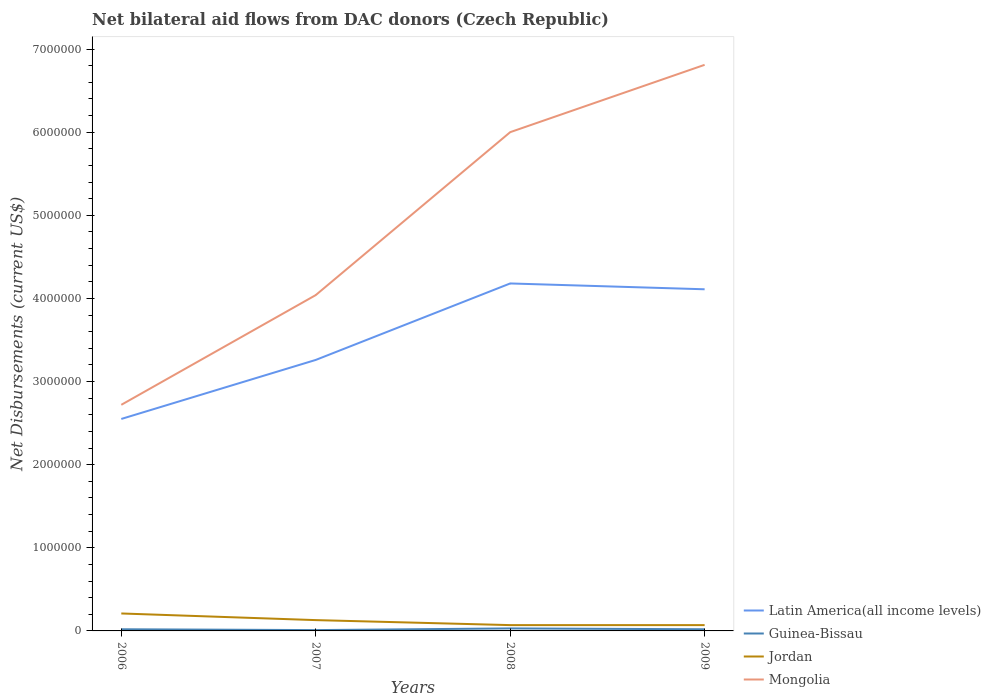How many different coloured lines are there?
Offer a terse response. 4. Across all years, what is the maximum net bilateral aid flows in Mongolia?
Your answer should be very brief. 2.72e+06. What is the total net bilateral aid flows in Mongolia in the graph?
Your answer should be very brief. -4.09e+06. Is the net bilateral aid flows in Jordan strictly greater than the net bilateral aid flows in Latin America(all income levels) over the years?
Your answer should be compact. Yes. How many lines are there?
Provide a short and direct response. 4. Does the graph contain any zero values?
Make the answer very short. No. Where does the legend appear in the graph?
Ensure brevity in your answer.  Bottom right. How are the legend labels stacked?
Make the answer very short. Vertical. What is the title of the graph?
Your answer should be compact. Net bilateral aid flows from DAC donors (Czech Republic). Does "Gambia, The" appear as one of the legend labels in the graph?
Offer a terse response. No. What is the label or title of the X-axis?
Offer a very short reply. Years. What is the label or title of the Y-axis?
Offer a very short reply. Net Disbursements (current US$). What is the Net Disbursements (current US$) of Latin America(all income levels) in 2006?
Provide a succinct answer. 2.55e+06. What is the Net Disbursements (current US$) in Jordan in 2006?
Keep it short and to the point. 2.10e+05. What is the Net Disbursements (current US$) of Mongolia in 2006?
Keep it short and to the point. 2.72e+06. What is the Net Disbursements (current US$) in Latin America(all income levels) in 2007?
Offer a terse response. 3.26e+06. What is the Net Disbursements (current US$) of Guinea-Bissau in 2007?
Give a very brief answer. 10000. What is the Net Disbursements (current US$) of Jordan in 2007?
Offer a terse response. 1.30e+05. What is the Net Disbursements (current US$) of Mongolia in 2007?
Keep it short and to the point. 4.04e+06. What is the Net Disbursements (current US$) in Latin America(all income levels) in 2008?
Your answer should be compact. 4.18e+06. What is the Net Disbursements (current US$) of Guinea-Bissau in 2008?
Your answer should be compact. 3.00e+04. What is the Net Disbursements (current US$) in Latin America(all income levels) in 2009?
Give a very brief answer. 4.11e+06. What is the Net Disbursements (current US$) of Guinea-Bissau in 2009?
Your response must be concise. 2.00e+04. What is the Net Disbursements (current US$) in Mongolia in 2009?
Give a very brief answer. 6.81e+06. Across all years, what is the maximum Net Disbursements (current US$) of Latin America(all income levels)?
Offer a very short reply. 4.18e+06. Across all years, what is the maximum Net Disbursements (current US$) of Guinea-Bissau?
Provide a short and direct response. 3.00e+04. Across all years, what is the maximum Net Disbursements (current US$) of Mongolia?
Provide a short and direct response. 6.81e+06. Across all years, what is the minimum Net Disbursements (current US$) of Latin America(all income levels)?
Offer a terse response. 2.55e+06. Across all years, what is the minimum Net Disbursements (current US$) in Mongolia?
Your answer should be very brief. 2.72e+06. What is the total Net Disbursements (current US$) in Latin America(all income levels) in the graph?
Make the answer very short. 1.41e+07. What is the total Net Disbursements (current US$) in Mongolia in the graph?
Your answer should be compact. 1.96e+07. What is the difference between the Net Disbursements (current US$) of Latin America(all income levels) in 2006 and that in 2007?
Make the answer very short. -7.10e+05. What is the difference between the Net Disbursements (current US$) of Guinea-Bissau in 2006 and that in 2007?
Provide a short and direct response. 10000. What is the difference between the Net Disbursements (current US$) of Jordan in 2006 and that in 2007?
Your answer should be very brief. 8.00e+04. What is the difference between the Net Disbursements (current US$) of Mongolia in 2006 and that in 2007?
Your answer should be compact. -1.32e+06. What is the difference between the Net Disbursements (current US$) in Latin America(all income levels) in 2006 and that in 2008?
Keep it short and to the point. -1.63e+06. What is the difference between the Net Disbursements (current US$) of Jordan in 2006 and that in 2008?
Ensure brevity in your answer.  1.40e+05. What is the difference between the Net Disbursements (current US$) in Mongolia in 2006 and that in 2008?
Offer a terse response. -3.28e+06. What is the difference between the Net Disbursements (current US$) of Latin America(all income levels) in 2006 and that in 2009?
Provide a succinct answer. -1.56e+06. What is the difference between the Net Disbursements (current US$) in Mongolia in 2006 and that in 2009?
Ensure brevity in your answer.  -4.09e+06. What is the difference between the Net Disbursements (current US$) in Latin America(all income levels) in 2007 and that in 2008?
Keep it short and to the point. -9.20e+05. What is the difference between the Net Disbursements (current US$) in Mongolia in 2007 and that in 2008?
Keep it short and to the point. -1.96e+06. What is the difference between the Net Disbursements (current US$) of Latin America(all income levels) in 2007 and that in 2009?
Your answer should be very brief. -8.50e+05. What is the difference between the Net Disbursements (current US$) of Guinea-Bissau in 2007 and that in 2009?
Make the answer very short. -10000. What is the difference between the Net Disbursements (current US$) in Jordan in 2007 and that in 2009?
Offer a terse response. 6.00e+04. What is the difference between the Net Disbursements (current US$) in Mongolia in 2007 and that in 2009?
Your answer should be compact. -2.77e+06. What is the difference between the Net Disbursements (current US$) in Latin America(all income levels) in 2008 and that in 2009?
Give a very brief answer. 7.00e+04. What is the difference between the Net Disbursements (current US$) in Guinea-Bissau in 2008 and that in 2009?
Offer a terse response. 10000. What is the difference between the Net Disbursements (current US$) of Mongolia in 2008 and that in 2009?
Offer a very short reply. -8.10e+05. What is the difference between the Net Disbursements (current US$) of Latin America(all income levels) in 2006 and the Net Disbursements (current US$) of Guinea-Bissau in 2007?
Keep it short and to the point. 2.54e+06. What is the difference between the Net Disbursements (current US$) of Latin America(all income levels) in 2006 and the Net Disbursements (current US$) of Jordan in 2007?
Offer a very short reply. 2.42e+06. What is the difference between the Net Disbursements (current US$) in Latin America(all income levels) in 2006 and the Net Disbursements (current US$) in Mongolia in 2007?
Your response must be concise. -1.49e+06. What is the difference between the Net Disbursements (current US$) in Guinea-Bissau in 2006 and the Net Disbursements (current US$) in Jordan in 2007?
Your answer should be very brief. -1.10e+05. What is the difference between the Net Disbursements (current US$) in Guinea-Bissau in 2006 and the Net Disbursements (current US$) in Mongolia in 2007?
Make the answer very short. -4.02e+06. What is the difference between the Net Disbursements (current US$) in Jordan in 2006 and the Net Disbursements (current US$) in Mongolia in 2007?
Keep it short and to the point. -3.83e+06. What is the difference between the Net Disbursements (current US$) in Latin America(all income levels) in 2006 and the Net Disbursements (current US$) in Guinea-Bissau in 2008?
Make the answer very short. 2.52e+06. What is the difference between the Net Disbursements (current US$) of Latin America(all income levels) in 2006 and the Net Disbursements (current US$) of Jordan in 2008?
Your response must be concise. 2.48e+06. What is the difference between the Net Disbursements (current US$) in Latin America(all income levels) in 2006 and the Net Disbursements (current US$) in Mongolia in 2008?
Give a very brief answer. -3.45e+06. What is the difference between the Net Disbursements (current US$) of Guinea-Bissau in 2006 and the Net Disbursements (current US$) of Mongolia in 2008?
Make the answer very short. -5.98e+06. What is the difference between the Net Disbursements (current US$) in Jordan in 2006 and the Net Disbursements (current US$) in Mongolia in 2008?
Offer a very short reply. -5.79e+06. What is the difference between the Net Disbursements (current US$) of Latin America(all income levels) in 2006 and the Net Disbursements (current US$) of Guinea-Bissau in 2009?
Keep it short and to the point. 2.53e+06. What is the difference between the Net Disbursements (current US$) of Latin America(all income levels) in 2006 and the Net Disbursements (current US$) of Jordan in 2009?
Ensure brevity in your answer.  2.48e+06. What is the difference between the Net Disbursements (current US$) of Latin America(all income levels) in 2006 and the Net Disbursements (current US$) of Mongolia in 2009?
Keep it short and to the point. -4.26e+06. What is the difference between the Net Disbursements (current US$) of Guinea-Bissau in 2006 and the Net Disbursements (current US$) of Mongolia in 2009?
Ensure brevity in your answer.  -6.79e+06. What is the difference between the Net Disbursements (current US$) in Jordan in 2006 and the Net Disbursements (current US$) in Mongolia in 2009?
Give a very brief answer. -6.60e+06. What is the difference between the Net Disbursements (current US$) in Latin America(all income levels) in 2007 and the Net Disbursements (current US$) in Guinea-Bissau in 2008?
Your answer should be very brief. 3.23e+06. What is the difference between the Net Disbursements (current US$) in Latin America(all income levels) in 2007 and the Net Disbursements (current US$) in Jordan in 2008?
Your answer should be compact. 3.19e+06. What is the difference between the Net Disbursements (current US$) in Latin America(all income levels) in 2007 and the Net Disbursements (current US$) in Mongolia in 2008?
Ensure brevity in your answer.  -2.74e+06. What is the difference between the Net Disbursements (current US$) in Guinea-Bissau in 2007 and the Net Disbursements (current US$) in Jordan in 2008?
Give a very brief answer. -6.00e+04. What is the difference between the Net Disbursements (current US$) in Guinea-Bissau in 2007 and the Net Disbursements (current US$) in Mongolia in 2008?
Your response must be concise. -5.99e+06. What is the difference between the Net Disbursements (current US$) of Jordan in 2007 and the Net Disbursements (current US$) of Mongolia in 2008?
Your response must be concise. -5.87e+06. What is the difference between the Net Disbursements (current US$) of Latin America(all income levels) in 2007 and the Net Disbursements (current US$) of Guinea-Bissau in 2009?
Offer a very short reply. 3.24e+06. What is the difference between the Net Disbursements (current US$) of Latin America(all income levels) in 2007 and the Net Disbursements (current US$) of Jordan in 2009?
Keep it short and to the point. 3.19e+06. What is the difference between the Net Disbursements (current US$) of Latin America(all income levels) in 2007 and the Net Disbursements (current US$) of Mongolia in 2009?
Your answer should be very brief. -3.55e+06. What is the difference between the Net Disbursements (current US$) of Guinea-Bissau in 2007 and the Net Disbursements (current US$) of Mongolia in 2009?
Provide a succinct answer. -6.80e+06. What is the difference between the Net Disbursements (current US$) of Jordan in 2007 and the Net Disbursements (current US$) of Mongolia in 2009?
Provide a succinct answer. -6.68e+06. What is the difference between the Net Disbursements (current US$) in Latin America(all income levels) in 2008 and the Net Disbursements (current US$) in Guinea-Bissau in 2009?
Your answer should be very brief. 4.16e+06. What is the difference between the Net Disbursements (current US$) in Latin America(all income levels) in 2008 and the Net Disbursements (current US$) in Jordan in 2009?
Make the answer very short. 4.11e+06. What is the difference between the Net Disbursements (current US$) in Latin America(all income levels) in 2008 and the Net Disbursements (current US$) in Mongolia in 2009?
Offer a very short reply. -2.63e+06. What is the difference between the Net Disbursements (current US$) of Guinea-Bissau in 2008 and the Net Disbursements (current US$) of Mongolia in 2009?
Your response must be concise. -6.78e+06. What is the difference between the Net Disbursements (current US$) of Jordan in 2008 and the Net Disbursements (current US$) of Mongolia in 2009?
Give a very brief answer. -6.74e+06. What is the average Net Disbursements (current US$) of Latin America(all income levels) per year?
Ensure brevity in your answer.  3.52e+06. What is the average Net Disbursements (current US$) in Jordan per year?
Make the answer very short. 1.20e+05. What is the average Net Disbursements (current US$) in Mongolia per year?
Ensure brevity in your answer.  4.89e+06. In the year 2006, what is the difference between the Net Disbursements (current US$) in Latin America(all income levels) and Net Disbursements (current US$) in Guinea-Bissau?
Offer a very short reply. 2.53e+06. In the year 2006, what is the difference between the Net Disbursements (current US$) of Latin America(all income levels) and Net Disbursements (current US$) of Jordan?
Provide a succinct answer. 2.34e+06. In the year 2006, what is the difference between the Net Disbursements (current US$) of Guinea-Bissau and Net Disbursements (current US$) of Mongolia?
Offer a terse response. -2.70e+06. In the year 2006, what is the difference between the Net Disbursements (current US$) of Jordan and Net Disbursements (current US$) of Mongolia?
Provide a succinct answer. -2.51e+06. In the year 2007, what is the difference between the Net Disbursements (current US$) in Latin America(all income levels) and Net Disbursements (current US$) in Guinea-Bissau?
Make the answer very short. 3.25e+06. In the year 2007, what is the difference between the Net Disbursements (current US$) in Latin America(all income levels) and Net Disbursements (current US$) in Jordan?
Provide a succinct answer. 3.13e+06. In the year 2007, what is the difference between the Net Disbursements (current US$) in Latin America(all income levels) and Net Disbursements (current US$) in Mongolia?
Provide a succinct answer. -7.80e+05. In the year 2007, what is the difference between the Net Disbursements (current US$) of Guinea-Bissau and Net Disbursements (current US$) of Jordan?
Offer a very short reply. -1.20e+05. In the year 2007, what is the difference between the Net Disbursements (current US$) of Guinea-Bissau and Net Disbursements (current US$) of Mongolia?
Provide a short and direct response. -4.03e+06. In the year 2007, what is the difference between the Net Disbursements (current US$) in Jordan and Net Disbursements (current US$) in Mongolia?
Your answer should be very brief. -3.91e+06. In the year 2008, what is the difference between the Net Disbursements (current US$) of Latin America(all income levels) and Net Disbursements (current US$) of Guinea-Bissau?
Give a very brief answer. 4.15e+06. In the year 2008, what is the difference between the Net Disbursements (current US$) in Latin America(all income levels) and Net Disbursements (current US$) in Jordan?
Offer a very short reply. 4.11e+06. In the year 2008, what is the difference between the Net Disbursements (current US$) of Latin America(all income levels) and Net Disbursements (current US$) of Mongolia?
Keep it short and to the point. -1.82e+06. In the year 2008, what is the difference between the Net Disbursements (current US$) of Guinea-Bissau and Net Disbursements (current US$) of Jordan?
Ensure brevity in your answer.  -4.00e+04. In the year 2008, what is the difference between the Net Disbursements (current US$) of Guinea-Bissau and Net Disbursements (current US$) of Mongolia?
Offer a terse response. -5.97e+06. In the year 2008, what is the difference between the Net Disbursements (current US$) of Jordan and Net Disbursements (current US$) of Mongolia?
Keep it short and to the point. -5.93e+06. In the year 2009, what is the difference between the Net Disbursements (current US$) in Latin America(all income levels) and Net Disbursements (current US$) in Guinea-Bissau?
Provide a succinct answer. 4.09e+06. In the year 2009, what is the difference between the Net Disbursements (current US$) of Latin America(all income levels) and Net Disbursements (current US$) of Jordan?
Provide a succinct answer. 4.04e+06. In the year 2009, what is the difference between the Net Disbursements (current US$) of Latin America(all income levels) and Net Disbursements (current US$) of Mongolia?
Provide a short and direct response. -2.70e+06. In the year 2009, what is the difference between the Net Disbursements (current US$) of Guinea-Bissau and Net Disbursements (current US$) of Jordan?
Provide a short and direct response. -5.00e+04. In the year 2009, what is the difference between the Net Disbursements (current US$) in Guinea-Bissau and Net Disbursements (current US$) in Mongolia?
Keep it short and to the point. -6.79e+06. In the year 2009, what is the difference between the Net Disbursements (current US$) of Jordan and Net Disbursements (current US$) of Mongolia?
Offer a terse response. -6.74e+06. What is the ratio of the Net Disbursements (current US$) of Latin America(all income levels) in 2006 to that in 2007?
Your response must be concise. 0.78. What is the ratio of the Net Disbursements (current US$) in Jordan in 2006 to that in 2007?
Offer a terse response. 1.62. What is the ratio of the Net Disbursements (current US$) of Mongolia in 2006 to that in 2007?
Offer a very short reply. 0.67. What is the ratio of the Net Disbursements (current US$) of Latin America(all income levels) in 2006 to that in 2008?
Make the answer very short. 0.61. What is the ratio of the Net Disbursements (current US$) of Jordan in 2006 to that in 2008?
Give a very brief answer. 3. What is the ratio of the Net Disbursements (current US$) in Mongolia in 2006 to that in 2008?
Keep it short and to the point. 0.45. What is the ratio of the Net Disbursements (current US$) in Latin America(all income levels) in 2006 to that in 2009?
Your answer should be compact. 0.62. What is the ratio of the Net Disbursements (current US$) in Guinea-Bissau in 2006 to that in 2009?
Ensure brevity in your answer.  1. What is the ratio of the Net Disbursements (current US$) of Jordan in 2006 to that in 2009?
Your answer should be very brief. 3. What is the ratio of the Net Disbursements (current US$) in Mongolia in 2006 to that in 2009?
Give a very brief answer. 0.4. What is the ratio of the Net Disbursements (current US$) in Latin America(all income levels) in 2007 to that in 2008?
Ensure brevity in your answer.  0.78. What is the ratio of the Net Disbursements (current US$) of Guinea-Bissau in 2007 to that in 2008?
Make the answer very short. 0.33. What is the ratio of the Net Disbursements (current US$) of Jordan in 2007 to that in 2008?
Your response must be concise. 1.86. What is the ratio of the Net Disbursements (current US$) in Mongolia in 2007 to that in 2008?
Offer a terse response. 0.67. What is the ratio of the Net Disbursements (current US$) of Latin America(all income levels) in 2007 to that in 2009?
Your response must be concise. 0.79. What is the ratio of the Net Disbursements (current US$) in Guinea-Bissau in 2007 to that in 2009?
Make the answer very short. 0.5. What is the ratio of the Net Disbursements (current US$) of Jordan in 2007 to that in 2009?
Offer a very short reply. 1.86. What is the ratio of the Net Disbursements (current US$) in Mongolia in 2007 to that in 2009?
Provide a short and direct response. 0.59. What is the ratio of the Net Disbursements (current US$) of Latin America(all income levels) in 2008 to that in 2009?
Your answer should be compact. 1.02. What is the ratio of the Net Disbursements (current US$) of Mongolia in 2008 to that in 2009?
Your answer should be compact. 0.88. What is the difference between the highest and the second highest Net Disbursements (current US$) of Latin America(all income levels)?
Ensure brevity in your answer.  7.00e+04. What is the difference between the highest and the second highest Net Disbursements (current US$) in Guinea-Bissau?
Offer a terse response. 10000. What is the difference between the highest and the second highest Net Disbursements (current US$) of Jordan?
Keep it short and to the point. 8.00e+04. What is the difference between the highest and the second highest Net Disbursements (current US$) in Mongolia?
Ensure brevity in your answer.  8.10e+05. What is the difference between the highest and the lowest Net Disbursements (current US$) in Latin America(all income levels)?
Provide a succinct answer. 1.63e+06. What is the difference between the highest and the lowest Net Disbursements (current US$) of Guinea-Bissau?
Your response must be concise. 2.00e+04. What is the difference between the highest and the lowest Net Disbursements (current US$) of Mongolia?
Offer a very short reply. 4.09e+06. 